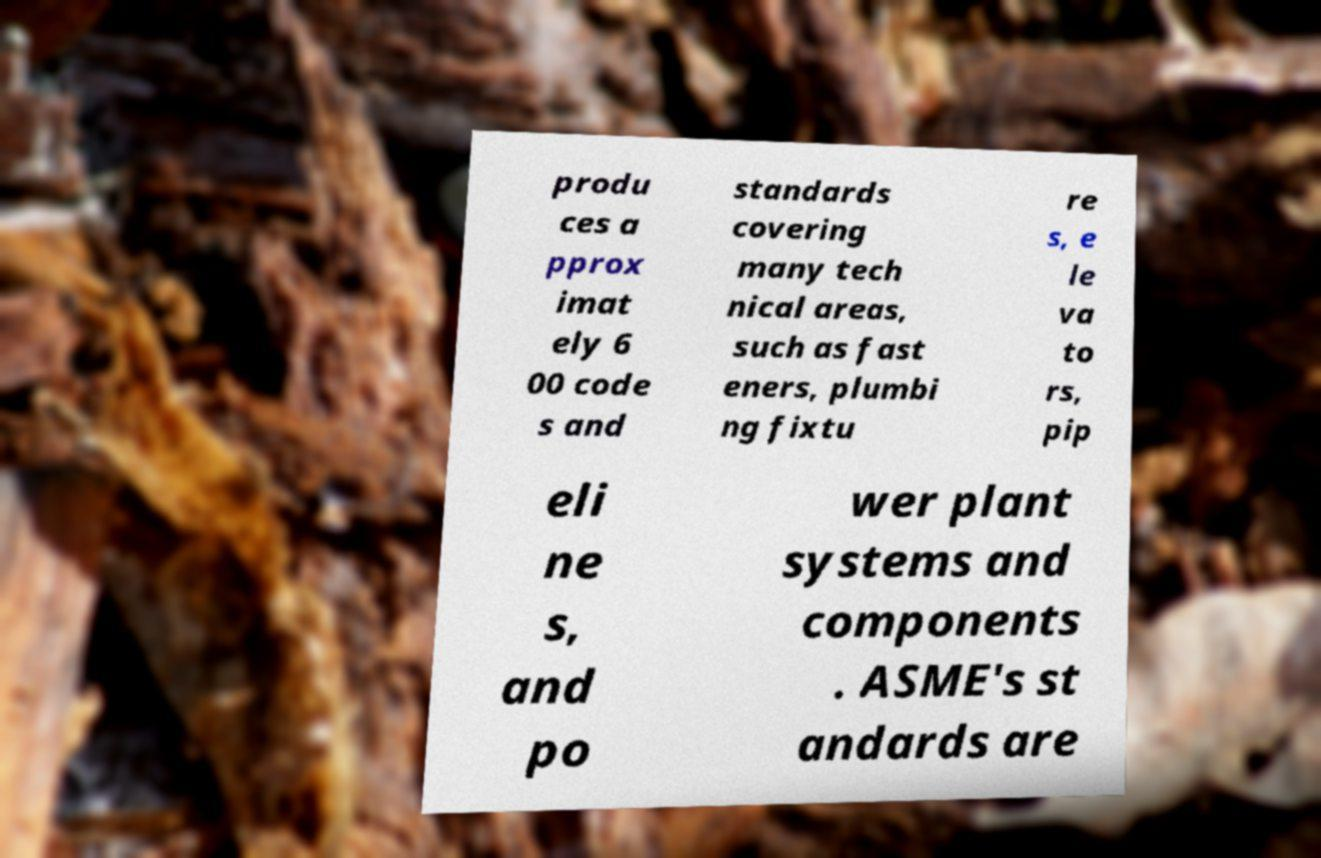What messages or text are displayed in this image? I need them in a readable, typed format. produ ces a pprox imat ely 6 00 code s and standards covering many tech nical areas, such as fast eners, plumbi ng fixtu re s, e le va to rs, pip eli ne s, and po wer plant systems and components . ASME's st andards are 